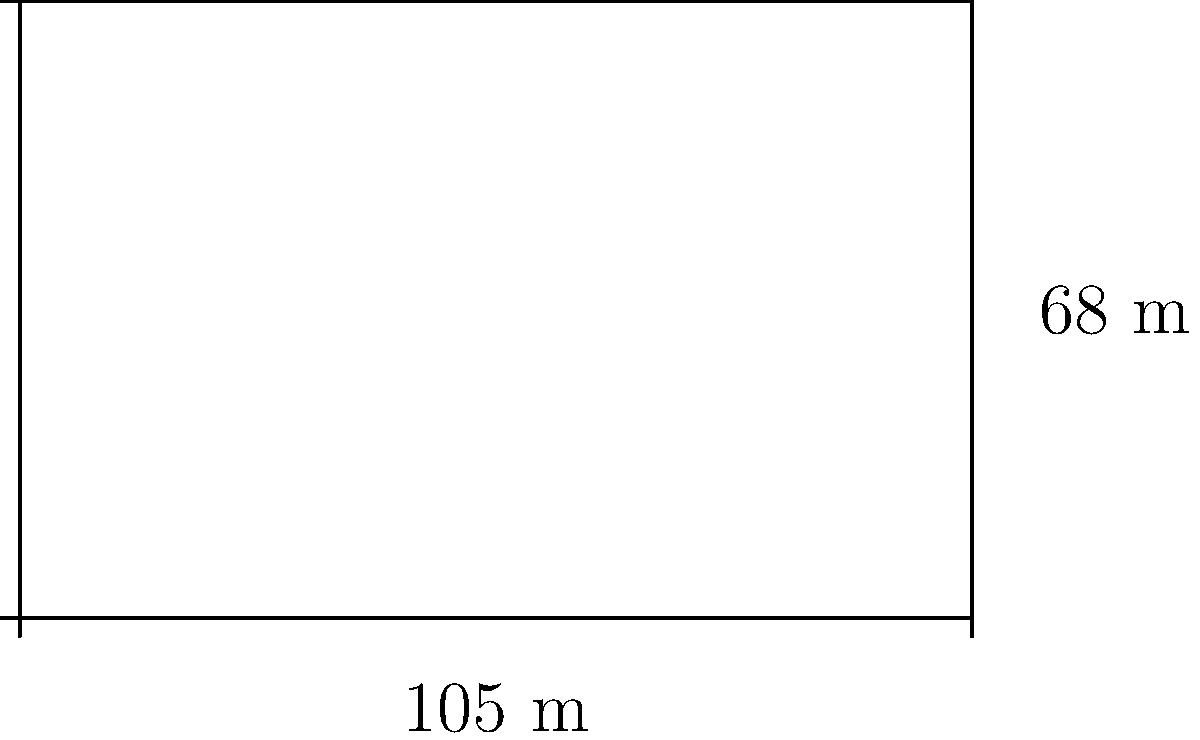As a sportswriter covering the Bundesliga, you're tasked with analyzing the playing surface at Signal Iduna Park, home of Borussia Dortmund. The pitch measures 105 meters in length and 68 meters in width. Calculate the total area of the playing surface in square meters. To calculate the area of a rectangular soccer field, we need to multiply its length by its width. Here's the step-by-step process:

1. Identify the dimensions:
   Length (l) = 105 meters
   Width (w) = 68 meters

2. Use the formula for the area of a rectangle:
   Area (A) = length × width
   A = l × w

3. Plug in the values:
   A = 105 m × 68 m

4. Perform the multiplication:
   A = 7,140 m²

Therefore, the total area of the playing surface at Signal Iduna Park is 7,140 square meters.
Answer: 7,140 m² 